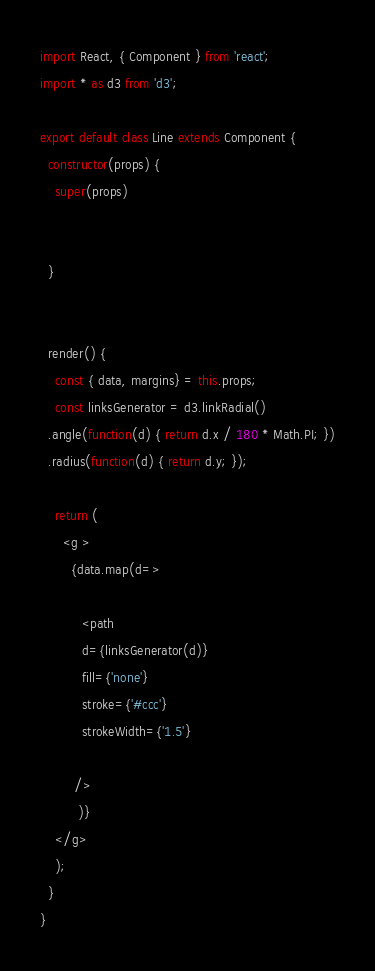<code> <loc_0><loc_0><loc_500><loc_500><_JavaScript_>import React, { Component } from 'react';
import * as d3 from 'd3';

export default class Line extends Component {
  constructor(props) {
    super(props)
 

  }
 
    
  render() {
    const { data, margins} = this.props;
    const linksGenerator = d3.linkRadial()
  .angle(function(d) { return d.x / 180 * Math.PI; })
  .radius(function(d) { return d.y; });
    
    return (
      <g >
        {data.map(d=>

           <path
           d={linksGenerator(d)}
           fill={'none'}
           stroke={'#ccc'}
           strokeWidth={'1.5'}
          
         />
          )}
    </g>
    );
  }
}</code> 